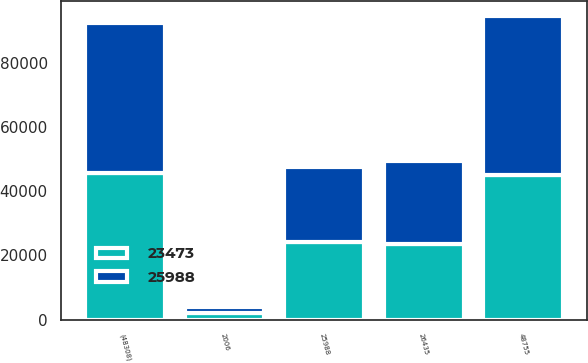Convert chart. <chart><loc_0><loc_0><loc_500><loc_500><stacked_bar_chart><ecel><fcel>2006<fcel>25988<fcel>(48308)<fcel>48755<fcel>26435<nl><fcel>25988<fcel>2005<fcel>23473<fcel>46850<fcel>49365<fcel>25988<nl><fcel>23473<fcel>2004<fcel>24063<fcel>45553<fcel>44963<fcel>23473<nl></chart> 